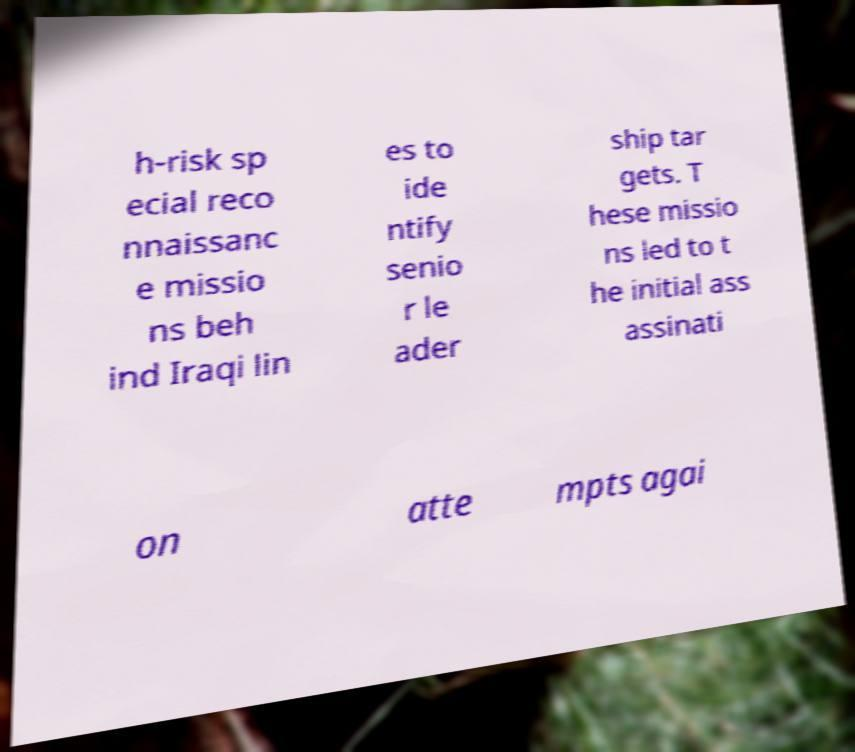What messages or text are displayed in this image? I need them in a readable, typed format. h-risk sp ecial reco nnaissanc e missio ns beh ind Iraqi lin es to ide ntify senio r le ader ship tar gets. T hese missio ns led to t he initial ass assinati on atte mpts agai 